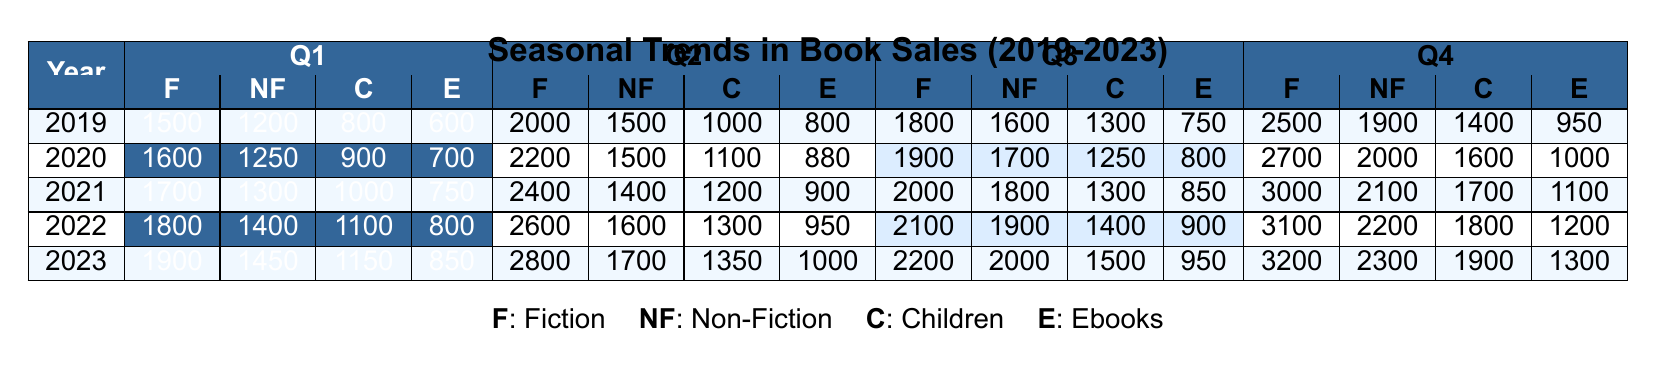What was the total sales of Fiction books in Q4 of 2021? The Q4 sales for Fiction books in 2021 is given as 3000. Therefore, the total sales in that quarter is simply the value stated in the table.
Answer: 3000 In which year did Non-Fiction sales peak in Q2? The Q2 sales data indicates that Non-Fiction books had their highest sales in 2022 at 1600. By observing the table, this is the maximum value within Q2 across the years listed.
Answer: 2022 What is the yearly trend of Children book sales from 2019 to 2023? By reviewing the quarterly sales of Children books over the five years, I notice the sales have generally increased each year. For instance, 800 in 2019, gradually increasing to 1900 in 2023. The rising numbers indicate a positive growth trend in Children book sales over the years.
Answer: Increasing How much did Fiction book sales increase from Q1 2020 to Q4 2020? First, identify the sales figures: Q1 2020 Fiction sales were 1600, and Q4 2020 Fiction sales were 2700. The increase is 2700 - 1600 = 1100. Thus, the fictional book sales increased by this amount from Q1 to Q4 in 2020.
Answer: 1100 Was there a decrease in Ebook sales in Q3 from 2019 to 2020? In 2019, the Ebook sales in Q3 were 750, while in 2020, they were 800. Therefore, there was no decrease; rather, there was an increase in Ebook sales in that quarter.
Answer: No What was the average Fiction book sales across all quarters in 2022? The total Fiction book sales for 2022 across all quarters: 1800 + 2600 + 2100 + 3100 = 9600. To calculate the average, divide this sum by 4 quarters: 9600 / 4 = 2400.
Answer: 2400 What were the Q4 sales figures for Non-Fiction books in the years 2019, 2021, and 2022? From the table, Q4 Non-Fiction sales are as follows: 2019: 1900, 2021: 2100, and 2022: 2200. These figures represent the specific Q4 sales for Non-Fiction books in those years.
Answer: 1900, 2100, 2200 Which quarter showed the highest sales in Children books during 2021? Reviewing the quarterly sales for Children books in 2021, the values are: Q1: 1000, Q2: 1200, Q3: 1300, and Q4: 1700. The highest sales occur in Q4 with 1700.
Answer: Q4 How do the total Q2 sales of Ebooks compare to Q3 sales for the year 2023? For the year 2023, Q2 Ebooks sales totaled 1000, while Q3 Ebooks sales totaled 950. Comparing these numbers, Q2 sales are higher than Q3 sales by 50.
Answer: Q2 sales are higher by 50 In which quarter did Fiction sales see the smallest increase between consecutive years, based on the data? By examining the increases between Q1 sales from 2019 to 2023: Q1 2019: 1500, Q1 2023: 1900 (increase of 400), Q2 2019: 2000, Q2 2023: 2800 (increase of 800), Q3 2019: 1800, Q3 2023: 2200 (increase of 400), Q4 also shows an increase from 2500 to 3200 (increase of 700). Both Q1 and Q3 had the smallest increase of 400.
Answer: Q1 and Q3 